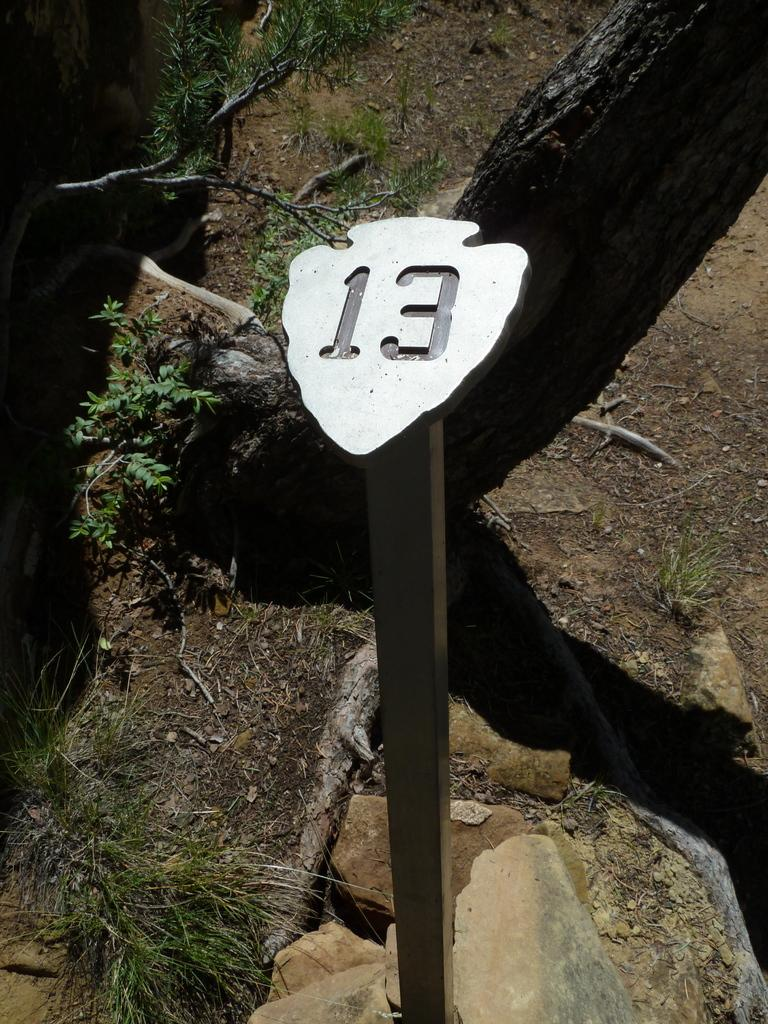What is the main object in the center of the image? There is a pole in the center of the image. What can be seen in the background of the image? There are rocks in the background of the image. What type of vegetation is visible in the image? There is grass visible in the image. What type of worm can be seen crawling on the guitar in the image? There is no guitar or worm present in the image. Is the scarecrow holding a sign in the image? There is no scarecrow present in the image. 